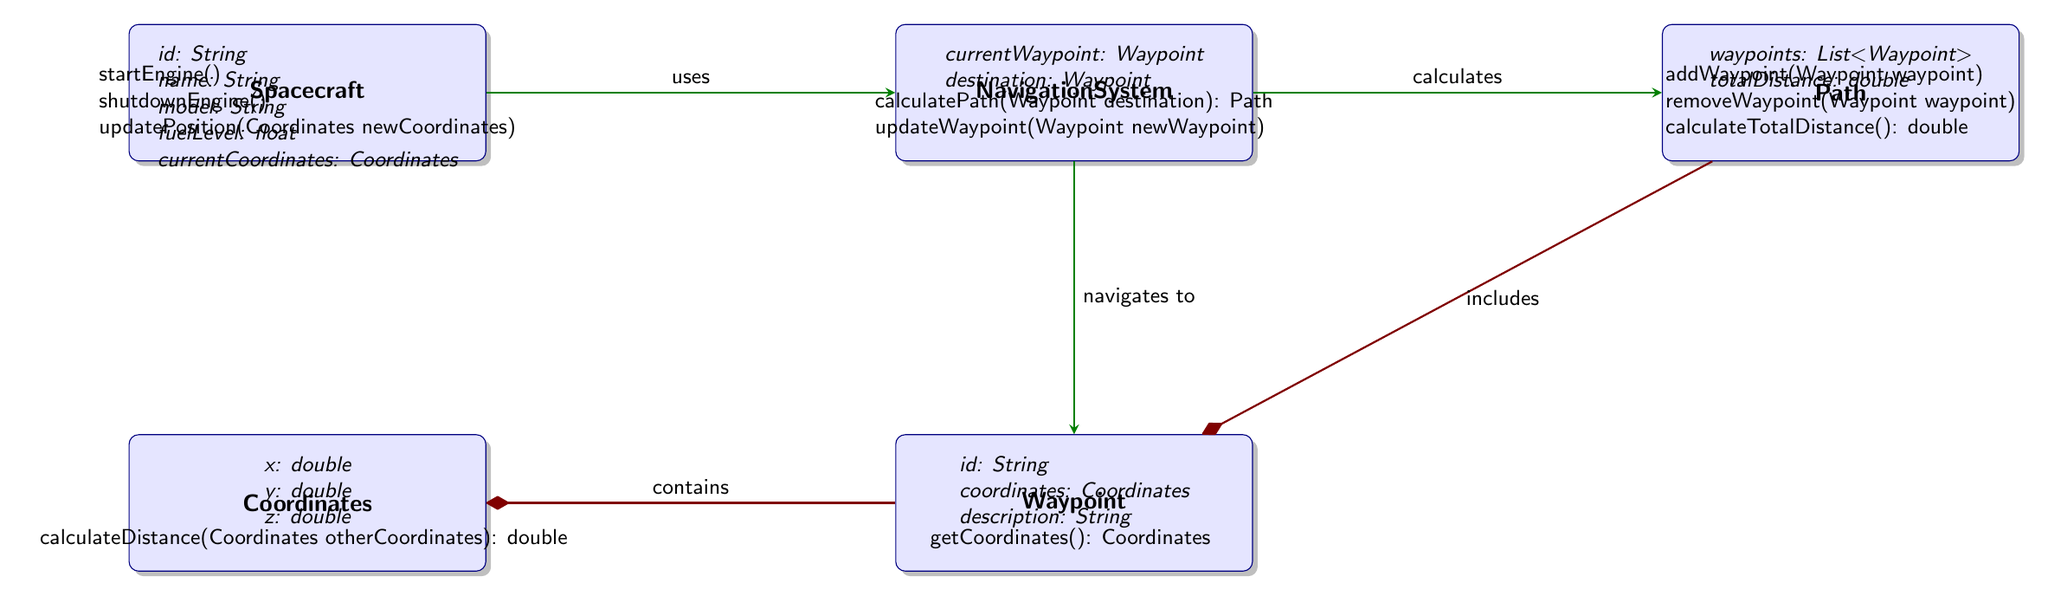What is the total number of classes in the diagram? The diagram includes five distinct classes: Spacecraft, Coordinates, NavigationSystem, Waypoint, and Path, which can be counted directly from the diagram nodes.
Answer: 5 What is the relationship between Spacecraft and NavigationSystem? The diagram shows an association arrow from Spacecraft to NavigationSystem labeled "uses", indicating that Spacecraft utilizes the NavigationSystem.
Answer: uses What is the method defined in the Coordinates class? The Coordinates class contains a single method presented as "calculateDistance(Coordinates otherCoordinates): double", which is listed under that class in the diagram.
Answer: calculateDistance(Coordinates otherCoordinates): double How many attributes does the Waypoint class have? The Waypoint class contains three attributes: id, coordinates, and description, as shown in the attributes section under that class.
Answer: 3 Which class directly contains the Coordinates? The diagram illustrates a composition relationship from Waypoint to Coordinates, indicating that Waypoint contains Coordinates.
Answer: Waypoint What does the Path class include? The Path class has a composition relationship with Waypoint labeled "includes", which specifies that it consists of multiple waypoints, which can be deduced from the attributes and method section under Path.
Answer: Waypoint What is the method in the Spacecraft class that involves position updates? The Spacecraft class includes the method "updatePosition(Coordinates newCoordinates)", indicating that this method is responsible for handling position updates.
Answer: updatePosition(Coordinates newCoordinates) How many methods are there in total across all classes? By counting the methods listed in each class (Spacecraft has 3, Coordinates has 1, NavigationSystem has 2, Waypoint has 1, Path has 3), the total comes to 10 methods.
Answer: 10 What type of relationship does NavigationSystem have with the Waypoint class? The NavigationSystem class has an association relationship with Waypoint, indicated by an arrow labeled "navigates to", showing a navigational connection.
Answer: navigates to 